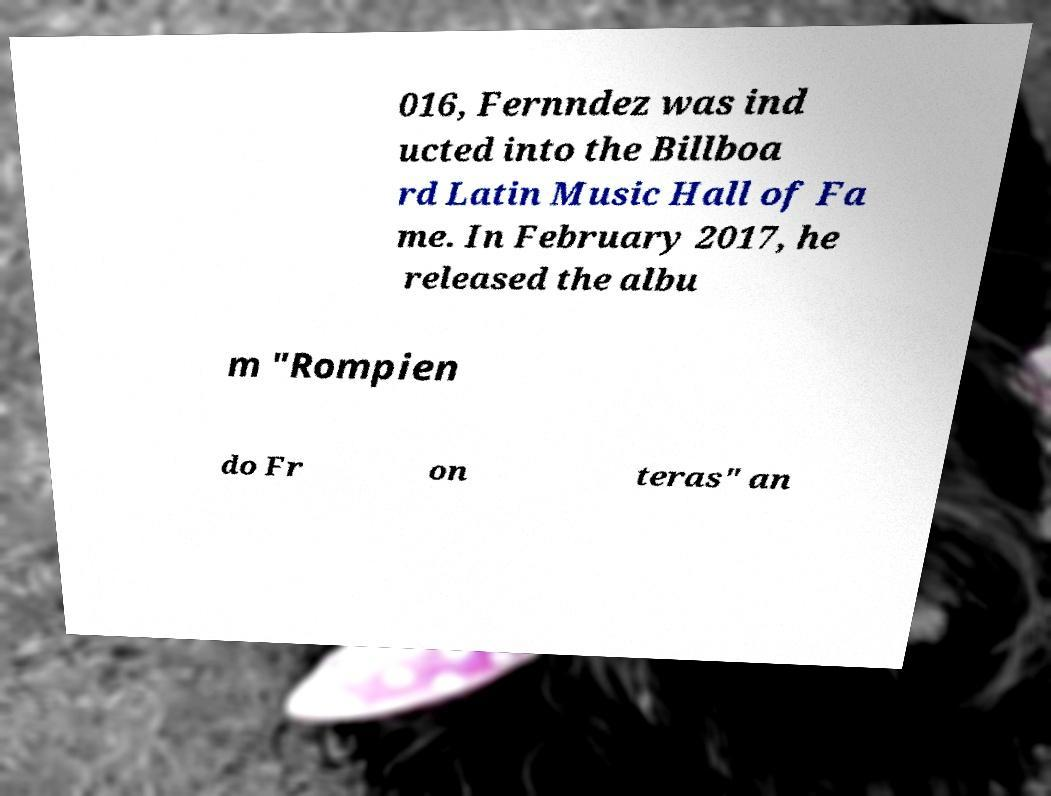For documentation purposes, I need the text within this image transcribed. Could you provide that? 016, Fernndez was ind ucted into the Billboa rd Latin Music Hall of Fa me. In February 2017, he released the albu m "Rompien do Fr on teras" an 